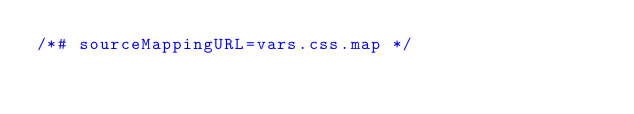Convert code to text. <code><loc_0><loc_0><loc_500><loc_500><_CSS_>/*# sourceMappingURL=vars.css.map */</code> 